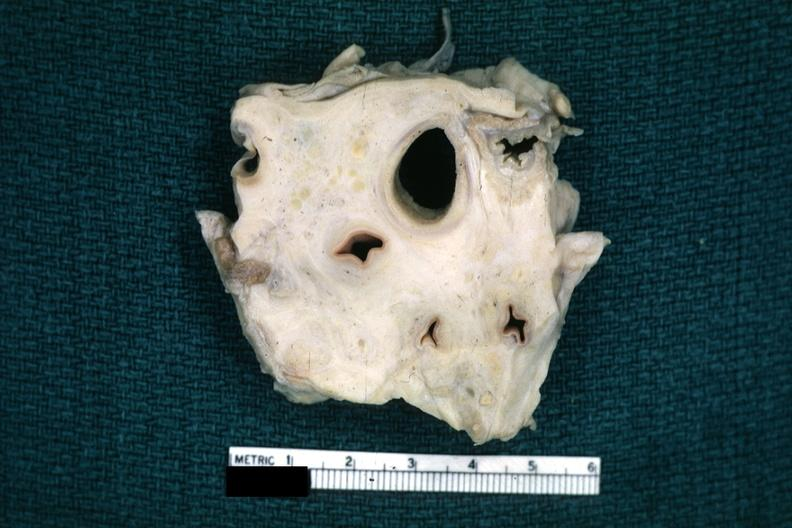what is present?
Answer the question using a single word or phrase. Metastatic carcinoma 